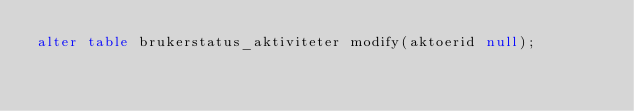Convert code to text. <code><loc_0><loc_0><loc_500><loc_500><_SQL_>alter table brukerstatus_aktiviteter modify(aktoerid null);</code> 